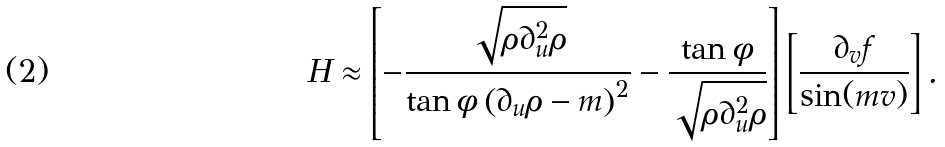Convert formula to latex. <formula><loc_0><loc_0><loc_500><loc_500>H \approx \left [ - \frac { \sqrt { \rho \partial _ { u } ^ { 2 } \rho } } { \tan \phi \left ( \partial _ { u } \rho - m \right ) ^ { 2 } } - \frac { \tan \phi } { \sqrt { \rho \partial _ { u } ^ { 2 } \rho } } \right ] \left [ \frac { \partial _ { v } f } { \sin ( m v ) } \right ] .</formula> 